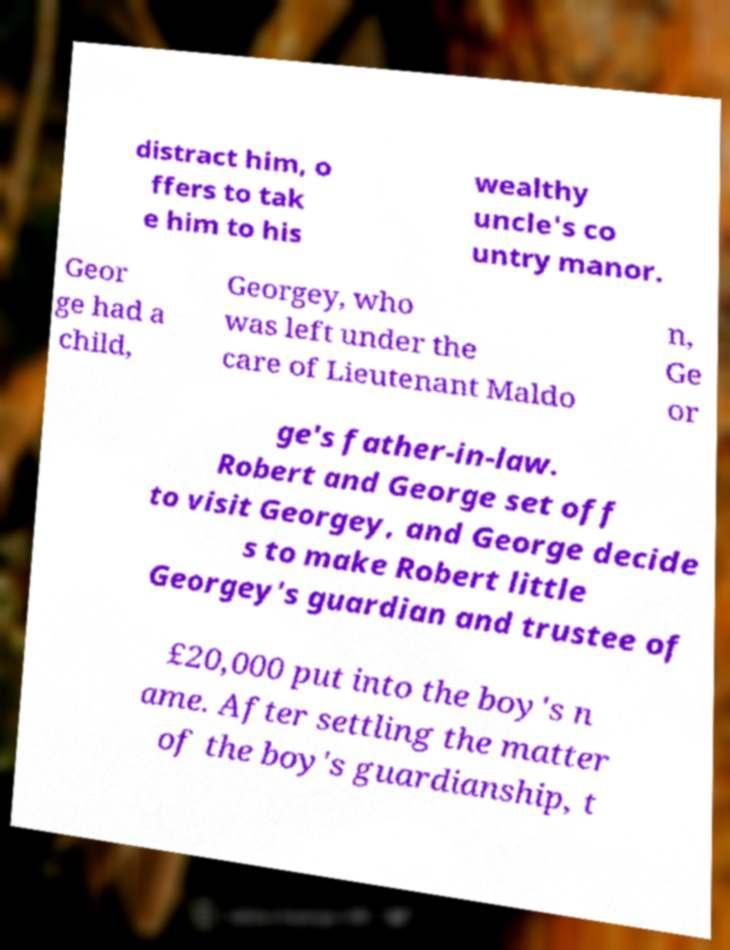I need the written content from this picture converted into text. Can you do that? distract him, o ffers to tak e him to his wealthy uncle's co untry manor. Geor ge had a child, Georgey, who was left under the care of Lieutenant Maldo n, Ge or ge's father-in-law. Robert and George set off to visit Georgey, and George decide s to make Robert little Georgey's guardian and trustee of £20,000 put into the boy's n ame. After settling the matter of the boy's guardianship, t 